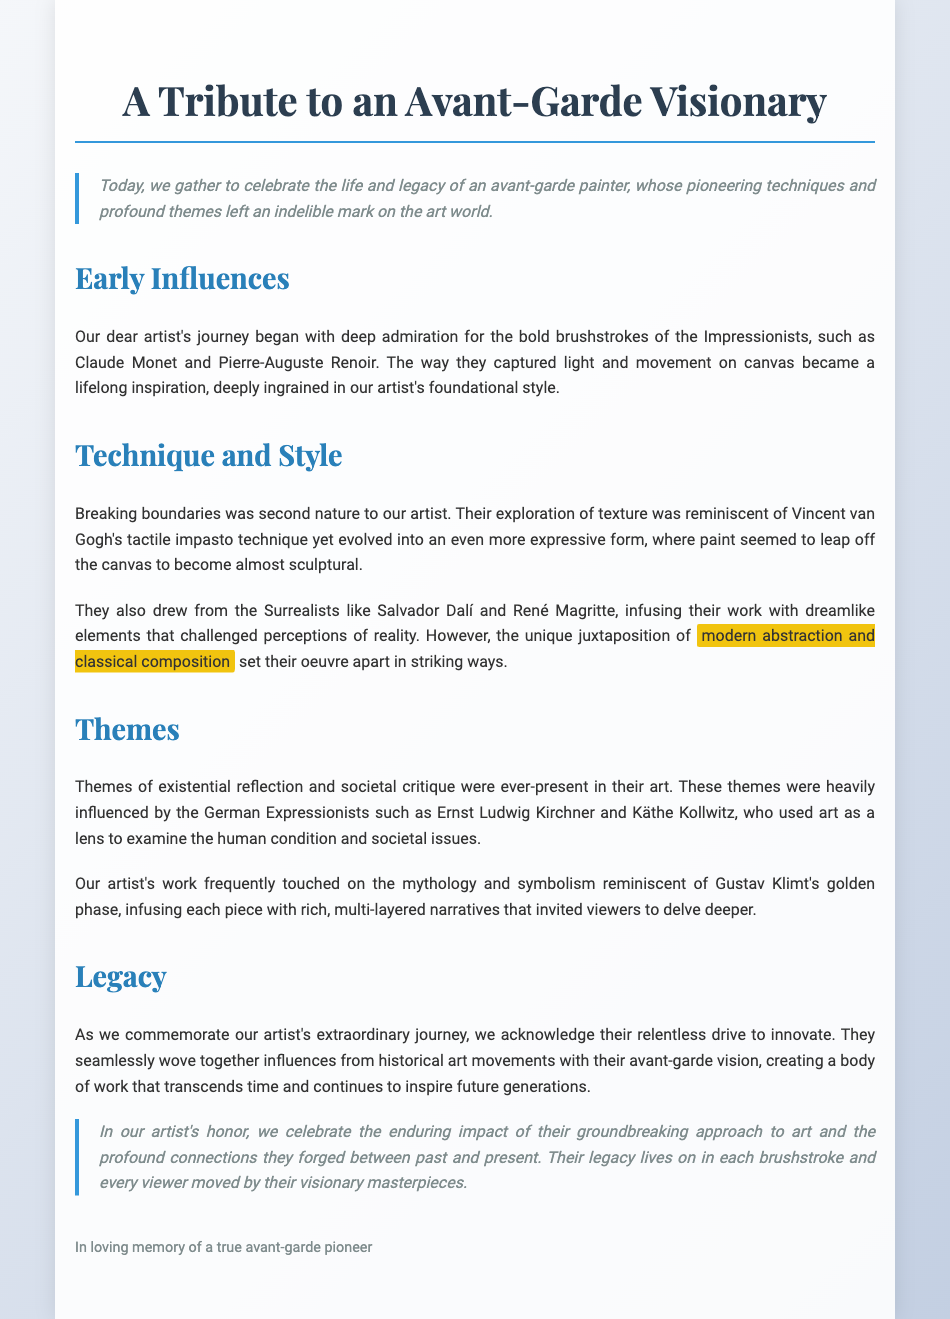What were the early influences on the artist? The artist's early influences included the bold brushstrokes of the Impressionists, such as Claude Monet and Pierre-Auguste Renoir.
Answer: Impressionists What technique was reminiscent of Vincent van Gogh? The artist's exploration of texture was reminiscent of Vincent van Gogh's tactile impasto technique.
Answer: Impasto Which Surrealist artists influenced the artist's work? The artist drew from surrealists like Salvador Dalí and René Magritte.
Answer: Salvador Dalí and René Magritte What type of themes were present in the artist's work? The artist's work frequently included themes of existential reflection and societal critique.
Answer: Existential reflection and societal critique What legacy did the artist leave behind? The artist created a body of work that transcends time and continues to inspire future generations.
Answer: Transcends time and inspires generations How did the artist differentiate their work from classical compositions? The unique juxtaposition of modern abstraction and classical composition set their oeuvre apart.
Answer: Modern abstraction and classical composition Who are the German Expressionists mentioned in the document? The German Expressionists mentioned include Ernst Ludwig Kirchner and Käthe Kollwitz.
Answer: Ernst Ludwig Kirchner and Käthe Kollwitz What phase of Gustav Klimt's work influenced the artist? The artist's work was influenced by Gustav Klimt's golden phase.
Answer: Golden phase 